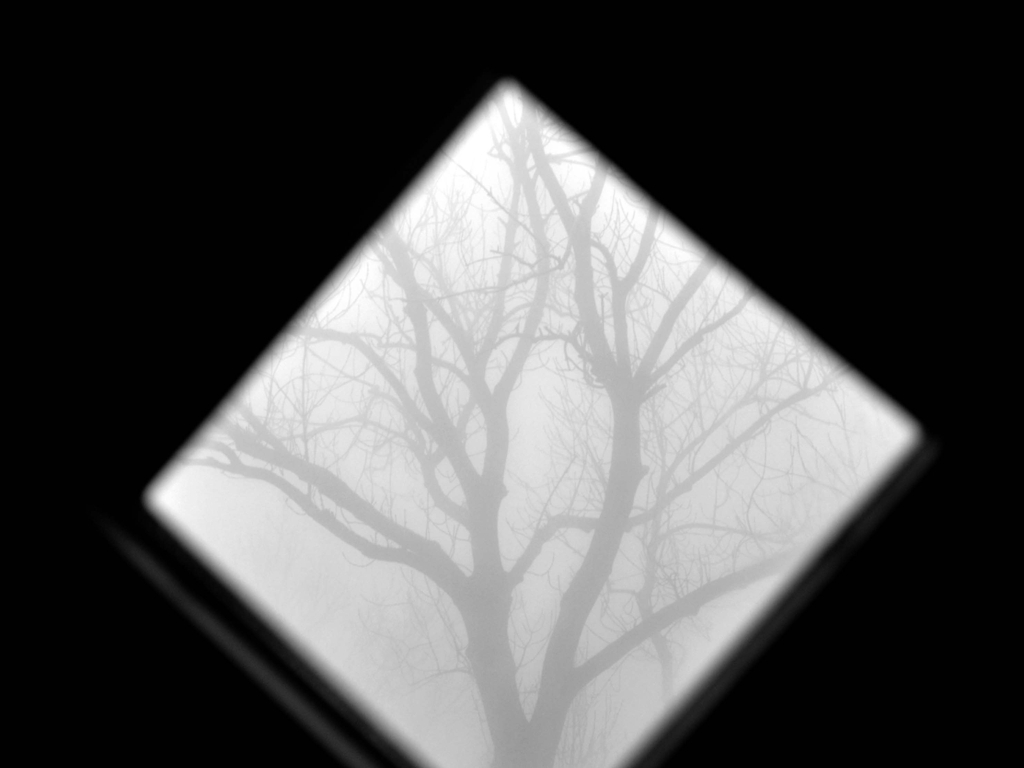How does the framing through an open square shape influence the perception of this image? The square frame within the image acts almost like a window or a lens, focusing the viewer's attention on the central tree and its branches. This geometric constraint adds a layer of structure to an otherwise chaotic and natural subject, allowing for a direct engagement with the tree's form against the foggy background. It can serve to impose order on natural randomness, or suggest a confined viewpoint from which we are urged to explore or break out. 